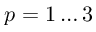<formula> <loc_0><loc_0><loc_500><loc_500>p = 1 \dots 3</formula> 